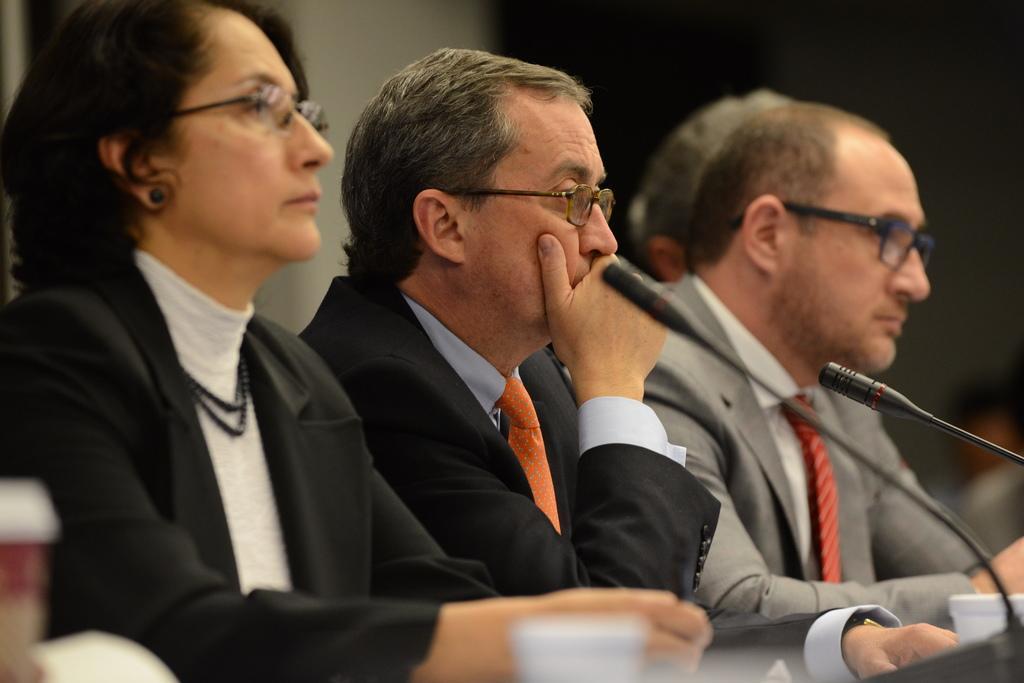How would you summarize this image in a sentence or two? In this image I can see few people and I can see all of them are wearing formal dress and specs. In the front of them I can see few glasses and two mics. I can also see this image is little bit blurry in the background. 